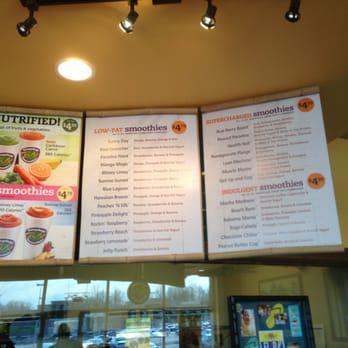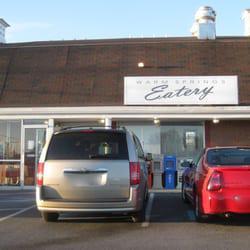The first image is the image on the left, the second image is the image on the right. For the images shown, is this caption "The right image shows a diner exterior with a rectangular sign over glass windows in front of a parking lot." true? Answer yes or no. Yes. The first image is the image on the left, the second image is the image on the right. Considering the images on both sides, is "Both images contain menus." valid? Answer yes or no. No. 